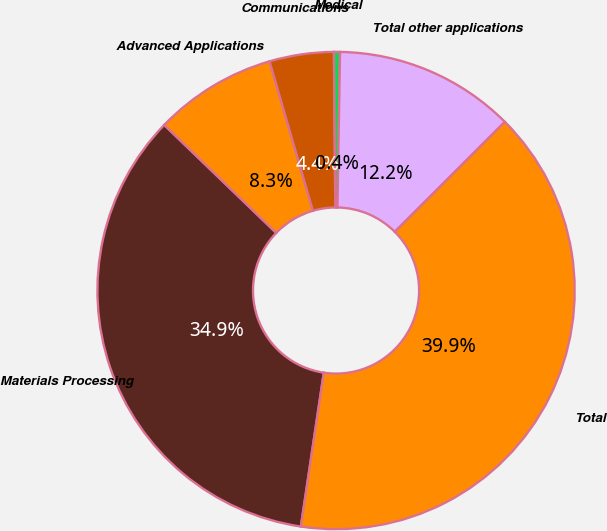<chart> <loc_0><loc_0><loc_500><loc_500><pie_chart><fcel>Materials Processing<fcel>Advanced Applications<fcel>Communications<fcel>Medical<fcel>Total other applications<fcel>Total<nl><fcel>34.85%<fcel>8.3%<fcel>4.35%<fcel>0.41%<fcel>12.24%<fcel>39.85%<nl></chart> 